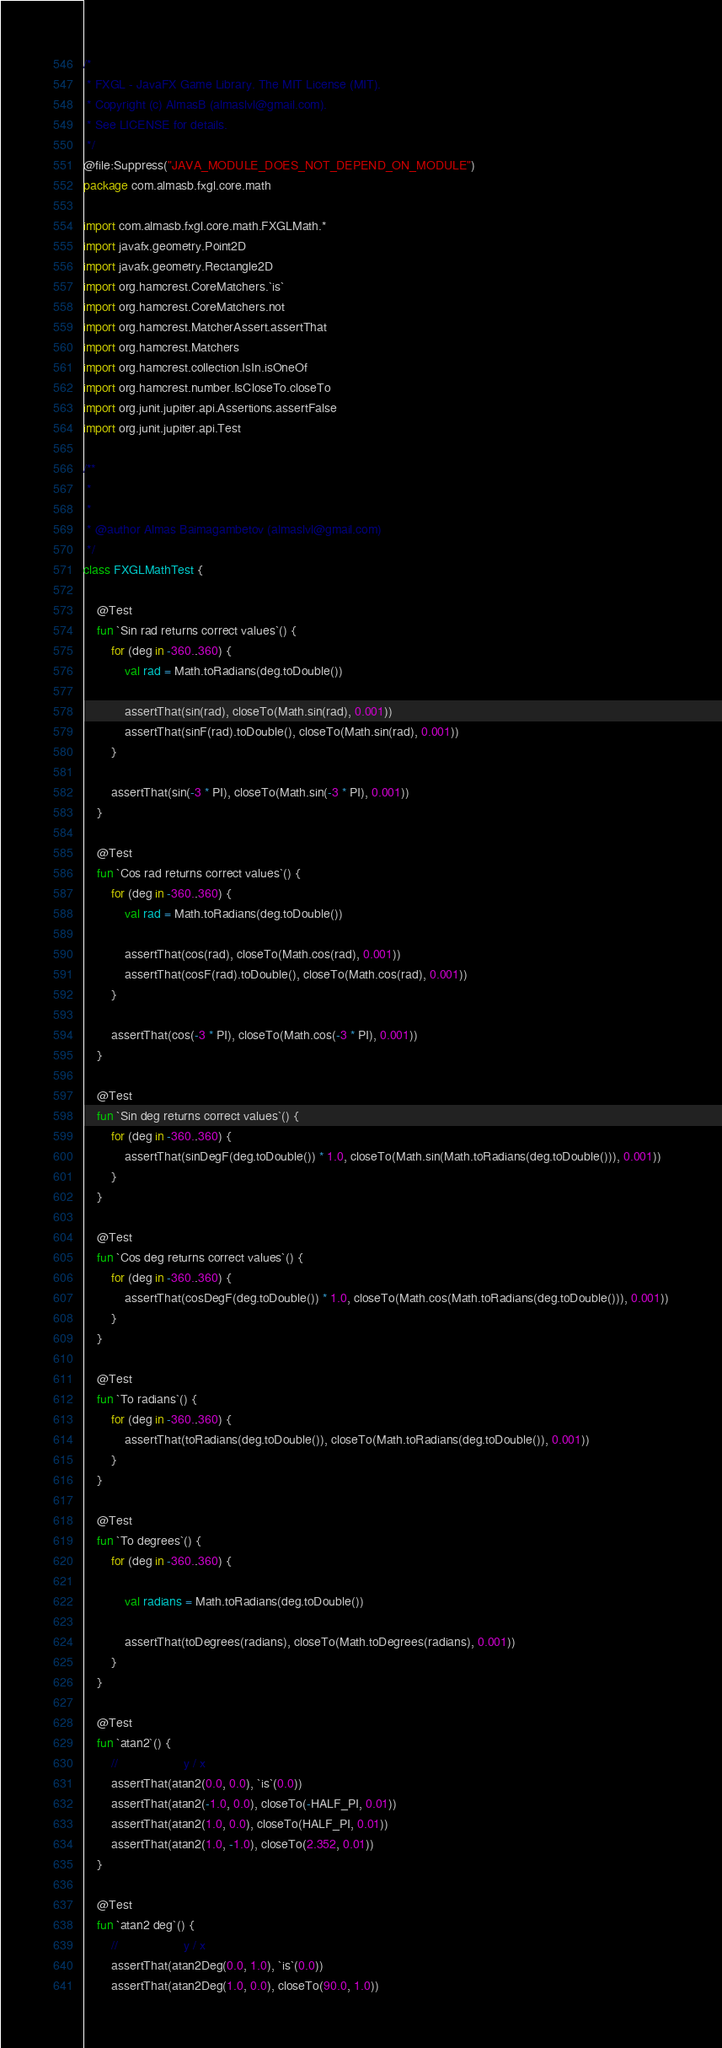<code> <loc_0><loc_0><loc_500><loc_500><_Kotlin_>/*
 * FXGL - JavaFX Game Library. The MIT License (MIT).
 * Copyright (c) AlmasB (almaslvl@gmail.com).
 * See LICENSE for details.
 */
@file:Suppress("JAVA_MODULE_DOES_NOT_DEPEND_ON_MODULE")
package com.almasb.fxgl.core.math

import com.almasb.fxgl.core.math.FXGLMath.*
import javafx.geometry.Point2D
import javafx.geometry.Rectangle2D
import org.hamcrest.CoreMatchers.`is`
import org.hamcrest.CoreMatchers.not
import org.hamcrest.MatcherAssert.assertThat
import org.hamcrest.Matchers
import org.hamcrest.collection.IsIn.isOneOf
import org.hamcrest.number.IsCloseTo.closeTo
import org.junit.jupiter.api.Assertions.assertFalse
import org.junit.jupiter.api.Test

/**
 *
 *
 * @author Almas Baimagambetov (almaslvl@gmail.com)
 */
class FXGLMathTest {

    @Test
    fun `Sin rad returns correct values`() {
        for (deg in -360..360) {
            val rad = Math.toRadians(deg.toDouble())

            assertThat(sin(rad), closeTo(Math.sin(rad), 0.001))
            assertThat(sinF(rad).toDouble(), closeTo(Math.sin(rad), 0.001))
        }

        assertThat(sin(-3 * PI), closeTo(Math.sin(-3 * PI), 0.001))
    }

    @Test
    fun `Cos rad returns correct values`() {
        for (deg in -360..360) {
            val rad = Math.toRadians(deg.toDouble())

            assertThat(cos(rad), closeTo(Math.cos(rad), 0.001))
            assertThat(cosF(rad).toDouble(), closeTo(Math.cos(rad), 0.001))
        }

        assertThat(cos(-3 * PI), closeTo(Math.cos(-3 * PI), 0.001))
    }

    @Test
    fun `Sin deg returns correct values`() {
        for (deg in -360..360) {
            assertThat(sinDegF(deg.toDouble()) * 1.0, closeTo(Math.sin(Math.toRadians(deg.toDouble())), 0.001))
        }
    }

    @Test
    fun `Cos deg returns correct values`() {
        for (deg in -360..360) {
            assertThat(cosDegF(deg.toDouble()) * 1.0, closeTo(Math.cos(Math.toRadians(deg.toDouble())), 0.001))
        }
    }

    @Test
    fun `To radians`() {
        for (deg in -360..360) {
            assertThat(toRadians(deg.toDouble()), closeTo(Math.toRadians(deg.toDouble()), 0.001))
        }
    }

    @Test
    fun `To degrees`() {
        for (deg in -360..360) {

            val radians = Math.toRadians(deg.toDouble())

            assertThat(toDegrees(radians), closeTo(Math.toDegrees(radians), 0.001))
        }
    }

    @Test
    fun `atan2`() {
        //                   y / x
        assertThat(atan2(0.0, 0.0), `is`(0.0))
        assertThat(atan2(-1.0, 0.0), closeTo(-HALF_PI, 0.01))
        assertThat(atan2(1.0, 0.0), closeTo(HALF_PI, 0.01))
        assertThat(atan2(1.0, -1.0), closeTo(2.352, 0.01))
    }

    @Test
    fun `atan2 deg`() {
        //                   y / x
        assertThat(atan2Deg(0.0, 1.0), `is`(0.0))
        assertThat(atan2Deg(1.0, 0.0), closeTo(90.0, 1.0))</code> 